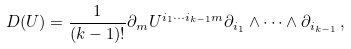Convert formula to latex. <formula><loc_0><loc_0><loc_500><loc_500>D ( U ) = \frac { 1 } { ( k - 1 ) ! } \partial _ { m } U ^ { i _ { 1 } \cdots i _ { k - 1 } m } \partial _ { i _ { 1 } } \wedge \cdots \wedge \partial _ { i _ { k - 1 } } \, ,</formula> 